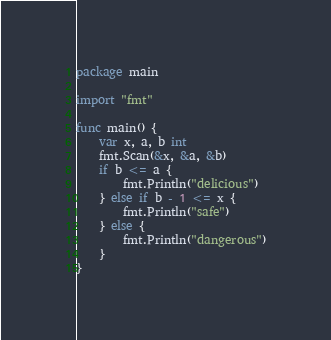<code> <loc_0><loc_0><loc_500><loc_500><_Go_>package main

import "fmt"

func main() {
	var x, a, b int
	fmt.Scan(&x, &a, &b)
	if b <= a {
		fmt.Println("delicious")
	} else if b - 1 <= x {
		fmt.Println("safe")
	} else {
		fmt.Println("dangerous")
	}
}
</code> 